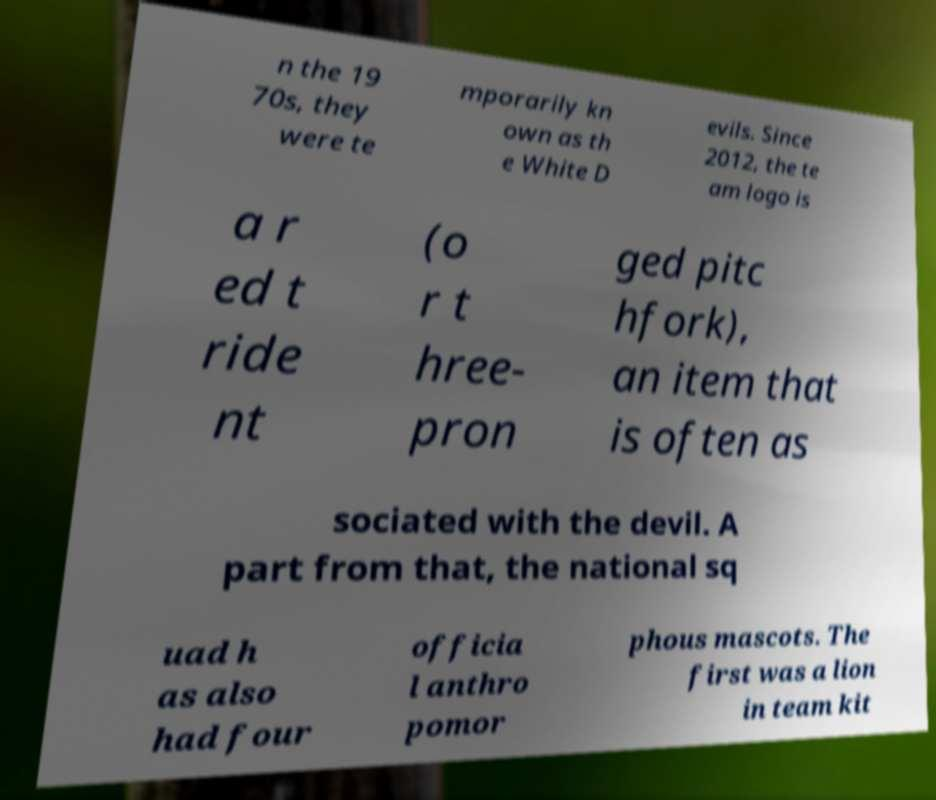Please read and relay the text visible in this image. What does it say? n the 19 70s, they were te mporarily kn own as th e White D evils. Since 2012, the te am logo is a r ed t ride nt (o r t hree- pron ged pitc hfork), an item that is often as sociated with the devil. A part from that, the national sq uad h as also had four officia l anthro pomor phous mascots. The first was a lion in team kit 